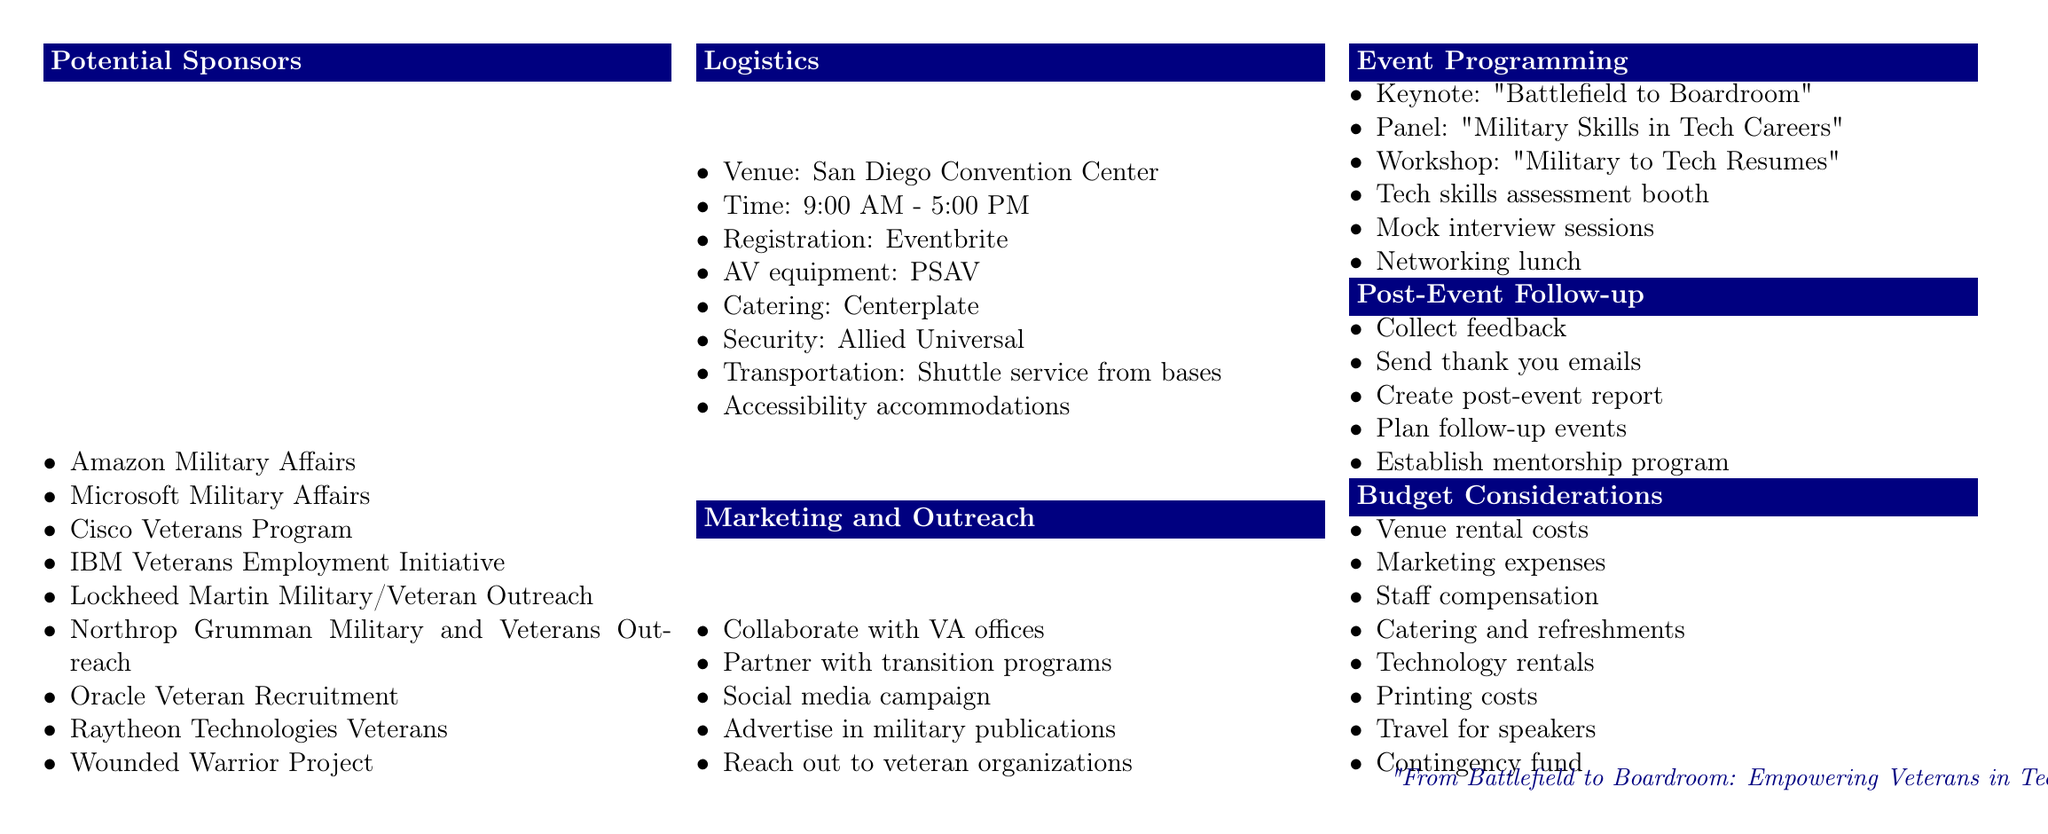What is the name of the event? The name of the event is mentioned at the top of the document under the title.
Answer: TechVets Career Fair 2023 Who is the keynote speaker? The keynote speaker is outlined in the Event Programming section of the document.
Answer: event organizer What is the date of the job fair? The date of the event is indicated in the header of the document.
Answer: October 15, 2023 Where will the event take place? The venue location is detailed in the Logistics section of the document.
Answer: San Diego Convention Center Which organization is responsible for the security? The entity providing security is found in the Logistics section.
Answer: Allied Universal Name one sponsor of the event. A list of sponsors is provided in the Potential Sponsors section.
Answer: Amazon Military Affairs What type of transportation will be provided? Transportation information is included in the Logistics section.
Answer: Shuttle service from nearby military bases What is one item included in the Budget Considerations? The Budget Considerations section lists various financial aspects of the event.
Answer: Venue rental costs How will feedback be collected after the event? The Post-Event Follow-up section outlines how feedback will be gathered.
Answer: Collect feedback from attendees and sponsors 